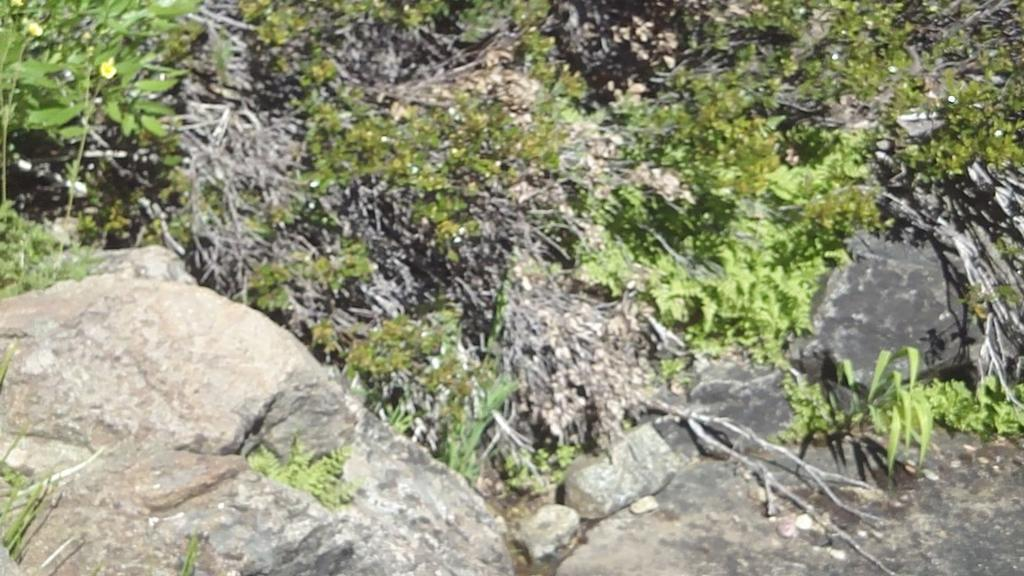What type of surface is visible in the image? There is a rock surface in the image. What is growing on the rock surface? There are small plants on the rock surface. What else can be seen on the rock surface? There are twigs on the rock surface. What type of battle is taking place in the image? There is no battle present in the image; it features a rock surface with small plants and twigs. Can you tell me how many planes are flying over the downtown area in the image? There is no downtown area or planes present in the image. 